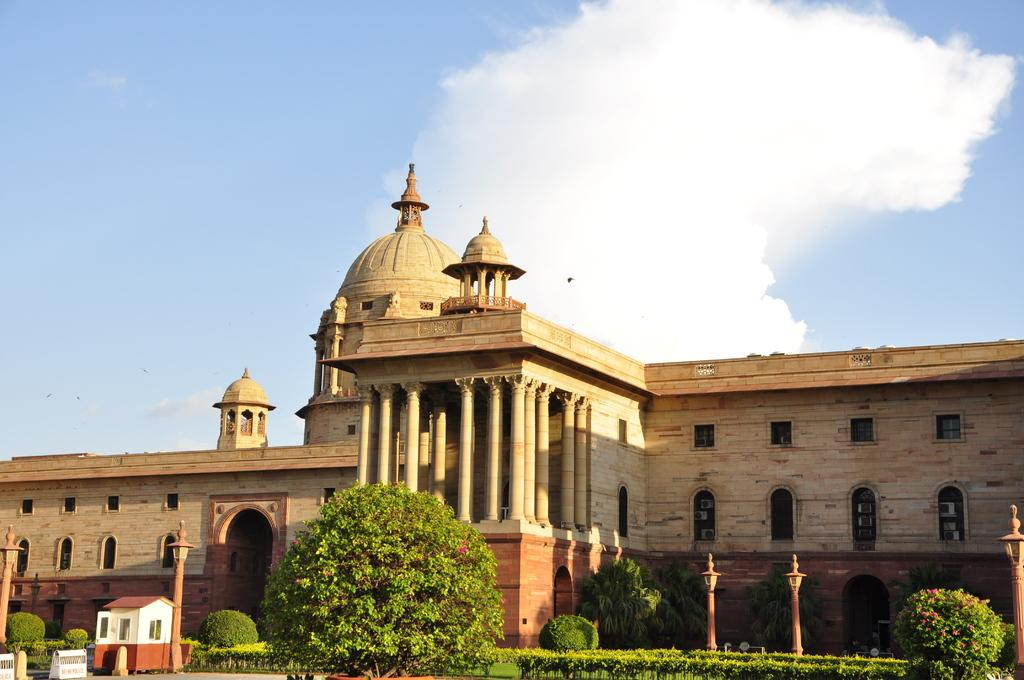What types of vegetation are at the bottom of the image? There are plants and trees at the bottom of the image. What structure can be seen in the background of the image? There is a building in the background of the image. What is visible at the top of the image? The sky is visible at the top of the image. What can be observed in the sky? Clouds are present in the sky. What type of cracker is being used to draw veins on the plants in the image? There is no cracker or drawing of veins on the plants in the image. Can you tell me how many snowflakes are visible on the building in the image? There is no snow or snowflakes visible on the building in the image. 